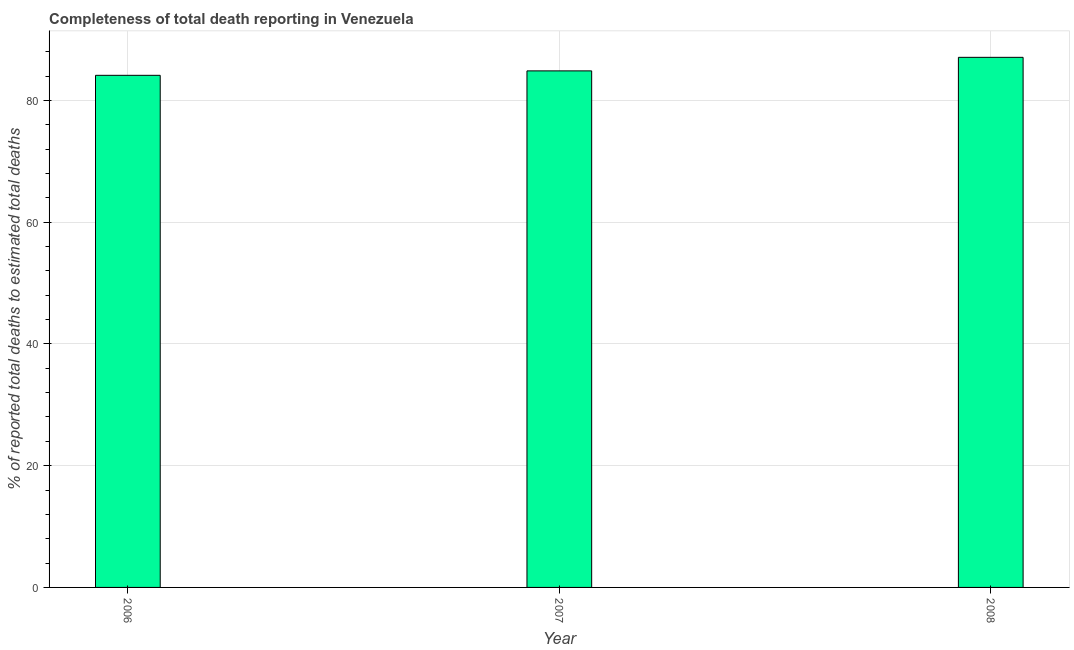Does the graph contain any zero values?
Make the answer very short. No. Does the graph contain grids?
Offer a terse response. Yes. What is the title of the graph?
Your response must be concise. Completeness of total death reporting in Venezuela. What is the label or title of the Y-axis?
Ensure brevity in your answer.  % of reported total deaths to estimated total deaths. What is the completeness of total death reports in 2006?
Give a very brief answer. 84.12. Across all years, what is the maximum completeness of total death reports?
Your answer should be very brief. 87.08. Across all years, what is the minimum completeness of total death reports?
Your response must be concise. 84.12. In which year was the completeness of total death reports maximum?
Ensure brevity in your answer.  2008. In which year was the completeness of total death reports minimum?
Offer a very short reply. 2006. What is the sum of the completeness of total death reports?
Offer a very short reply. 256.05. What is the difference between the completeness of total death reports in 2006 and 2008?
Give a very brief answer. -2.96. What is the average completeness of total death reports per year?
Your response must be concise. 85.35. What is the median completeness of total death reports?
Offer a terse response. 84.85. What is the ratio of the completeness of total death reports in 2006 to that in 2008?
Give a very brief answer. 0.97. Is the completeness of total death reports in 2006 less than that in 2007?
Offer a very short reply. Yes. Is the difference between the completeness of total death reports in 2007 and 2008 greater than the difference between any two years?
Ensure brevity in your answer.  No. What is the difference between the highest and the second highest completeness of total death reports?
Ensure brevity in your answer.  2.23. What is the difference between the highest and the lowest completeness of total death reports?
Make the answer very short. 2.96. How many bars are there?
Make the answer very short. 3. What is the difference between two consecutive major ticks on the Y-axis?
Make the answer very short. 20. What is the % of reported total deaths to estimated total deaths of 2006?
Provide a succinct answer. 84.12. What is the % of reported total deaths to estimated total deaths in 2007?
Provide a succinct answer. 84.85. What is the % of reported total deaths to estimated total deaths of 2008?
Ensure brevity in your answer.  87.08. What is the difference between the % of reported total deaths to estimated total deaths in 2006 and 2007?
Keep it short and to the point. -0.73. What is the difference between the % of reported total deaths to estimated total deaths in 2006 and 2008?
Make the answer very short. -2.96. What is the difference between the % of reported total deaths to estimated total deaths in 2007 and 2008?
Provide a succinct answer. -2.23. What is the ratio of the % of reported total deaths to estimated total deaths in 2006 to that in 2007?
Offer a very short reply. 0.99. What is the ratio of the % of reported total deaths to estimated total deaths in 2006 to that in 2008?
Provide a succinct answer. 0.97. What is the ratio of the % of reported total deaths to estimated total deaths in 2007 to that in 2008?
Your answer should be compact. 0.97. 